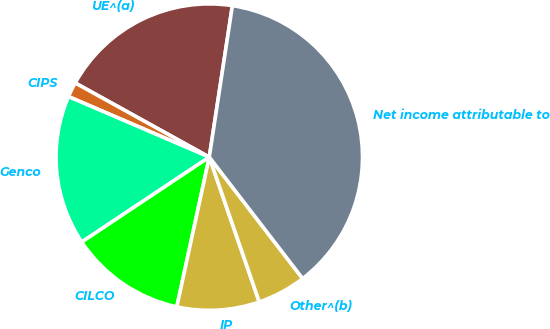Convert chart. <chart><loc_0><loc_0><loc_500><loc_500><pie_chart><fcel>UE^(a)<fcel>CIPS<fcel>Genco<fcel>CILCO<fcel>IP<fcel>Other^(b)<fcel>Net income attributable to<nl><fcel>19.37%<fcel>1.58%<fcel>15.81%<fcel>12.25%<fcel>8.69%<fcel>5.14%<fcel>37.16%<nl></chart> 